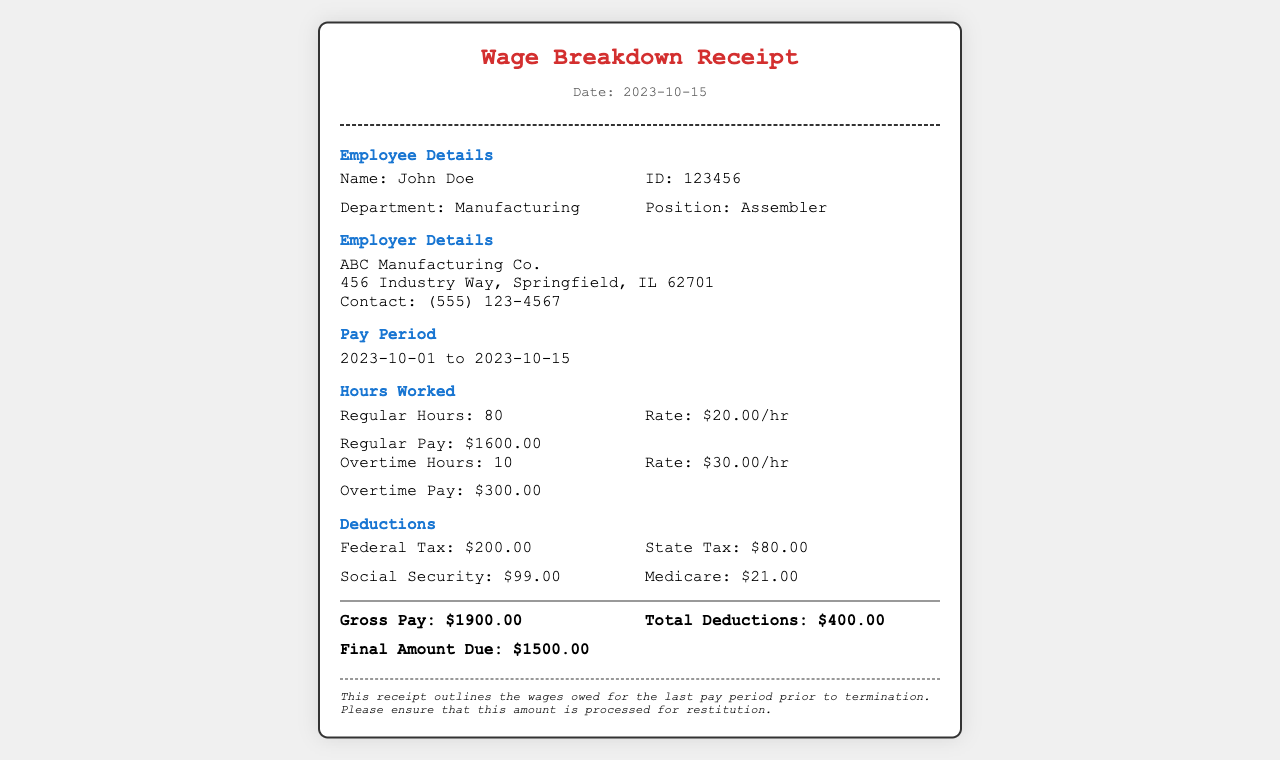What is the employee's name? The employee's name is John Doe, as mentioned in the Employee Details section.
Answer: John Doe What is the total amount of regular pay? The total amount of regular pay is specified as $1600.00 in the Hours Worked section.
Answer: $1600.00 How many overtime hours were worked? The document states that 10 overtime hours were worked, as listed in the Hours Worked section.
Answer: 10 What is the state tax deduction amount? The state tax deduction amount is provided as $80.00 in the Deductions section.
Answer: $80.00 What is the final amount due? The final amount due is stated as $1500.00 in the total section of the document.
Answer: $1500.00 How long was the pay period for this receipt? The pay period is from 2023-10-01 to 2023-10-15, which is given in the Pay Period section.
Answer: 2023-10-01 to 2023-10-15 What is the gross pay for the last pay period? The gross pay is noted as $1900.00 in the total section of the receipt.
Answer: $1900.00 Which company is the employer? The employer is listed as ABC Manufacturing Co. in the Employer Details section.
Answer: ABC Manufacturing Co 